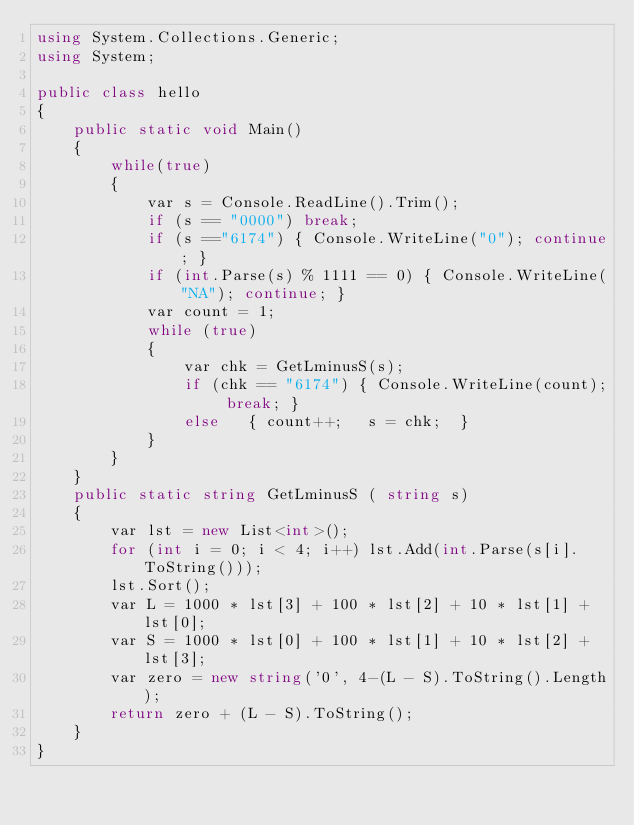<code> <loc_0><loc_0><loc_500><loc_500><_C#_>using System.Collections.Generic;
using System;

public class hello
{
    public static void Main()
    {
        while(true)
        {
            var s = Console.ReadLine().Trim();
            if (s == "0000") break;
            if (s =="6174") { Console.WriteLine("0"); continue; }
            if (int.Parse(s) % 1111 == 0) { Console.WriteLine("NA"); continue; }
            var count = 1;
            while (true)
            {
                var chk = GetLminusS(s);
                if (chk == "6174") { Console.WriteLine(count); break; }
                else   { count++;   s = chk;  }
            }
        }
    }
    public static string GetLminusS ( string s)
    {
        var lst = new List<int>();
        for (int i = 0; i < 4; i++) lst.Add(int.Parse(s[i].ToString()));
        lst.Sort();
        var L = 1000 * lst[3] + 100 * lst[2] + 10 * lst[1] + lst[0];
        var S = 1000 * lst[0] + 100 * lst[1] + 10 * lst[2] + lst[3];
        var zero = new string('0', 4-(L - S).ToString().Length);
        return zero + (L - S).ToString();
    }
}</code> 